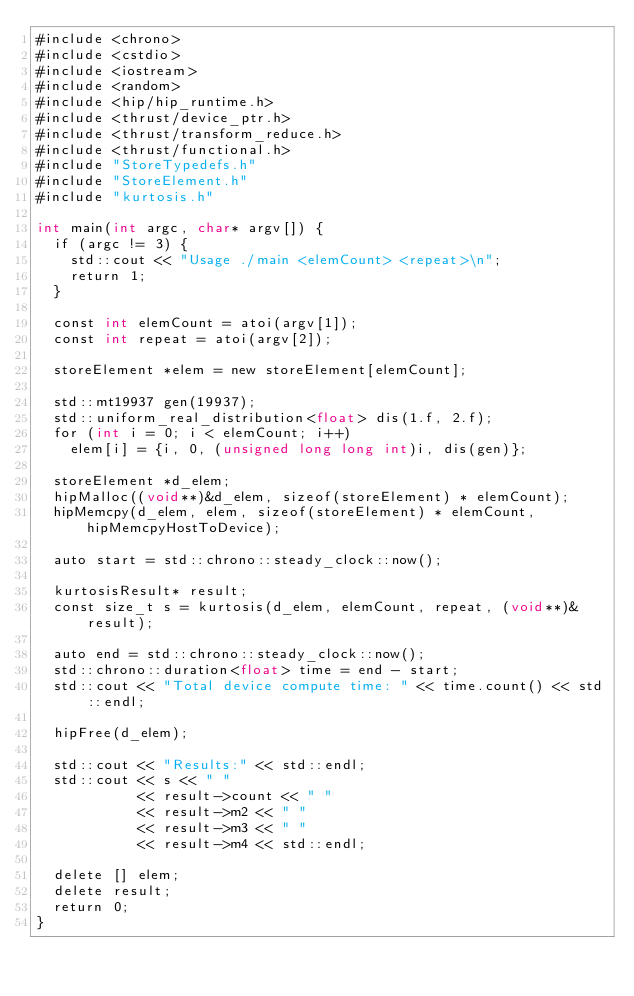Convert code to text. <code><loc_0><loc_0><loc_500><loc_500><_Cuda_>#include <chrono>
#include <cstdio>
#include <iostream>
#include <random>
#include <hip/hip_runtime.h>
#include <thrust/device_ptr.h>
#include <thrust/transform_reduce.h>
#include <thrust/functional.h>
#include "StoreTypedefs.h"
#include "StoreElement.h"
#include "kurtosis.h"

int main(int argc, char* argv[]) {
  if (argc != 3) {
    std::cout << "Usage ./main <elemCount> <repeat>\n";
    return 1;
  }

  const int elemCount = atoi(argv[1]);
  const int repeat = atoi(argv[2]);
    
  storeElement *elem = new storeElement[elemCount];

  std::mt19937 gen(19937);
  std::uniform_real_distribution<float> dis(1.f, 2.f);
  for (int i = 0; i < elemCount; i++)
    elem[i] = {i, 0, (unsigned long long int)i, dis(gen)};

  storeElement *d_elem;
  hipMalloc((void**)&d_elem, sizeof(storeElement) * elemCount);
  hipMemcpy(d_elem, elem, sizeof(storeElement) * elemCount, hipMemcpyHostToDevice);

  auto start = std::chrono::steady_clock::now();

  kurtosisResult* result;
  const size_t s = kurtosis(d_elem, elemCount, repeat, (void**)&result);

  auto end = std::chrono::steady_clock::now();
  std::chrono::duration<float> time = end - start;
  std::cout << "Total device compute time: " << time.count() << std::endl;
  
  hipFree(d_elem);

  std::cout << "Results:" << std::endl;
  std::cout << s << " "
            << result->count << " "
            << result->m2 << " "
            << result->m3 << " "
            << result->m4 << std::endl;

  delete [] elem;
  delete result;
  return 0;
}
</code> 